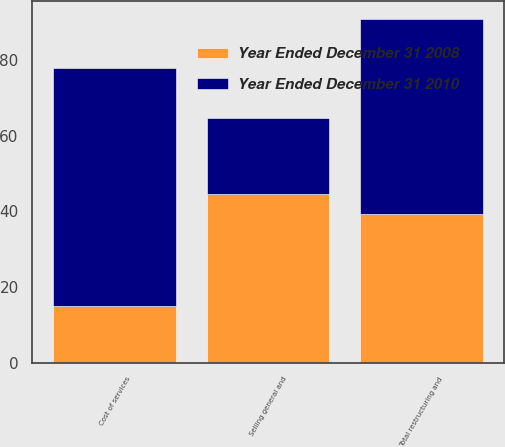Convert chart. <chart><loc_0><loc_0><loc_500><loc_500><stacked_bar_chart><ecel><fcel>Cost of services<fcel>Selling general and<fcel>Total restructuring and<nl><fcel>Year Ended December 31 2008<fcel>15<fcel>44.5<fcel>39.3<nl><fcel>Year Ended December 31 2010<fcel>62.8<fcel>20.1<fcel>51.6<nl></chart> 